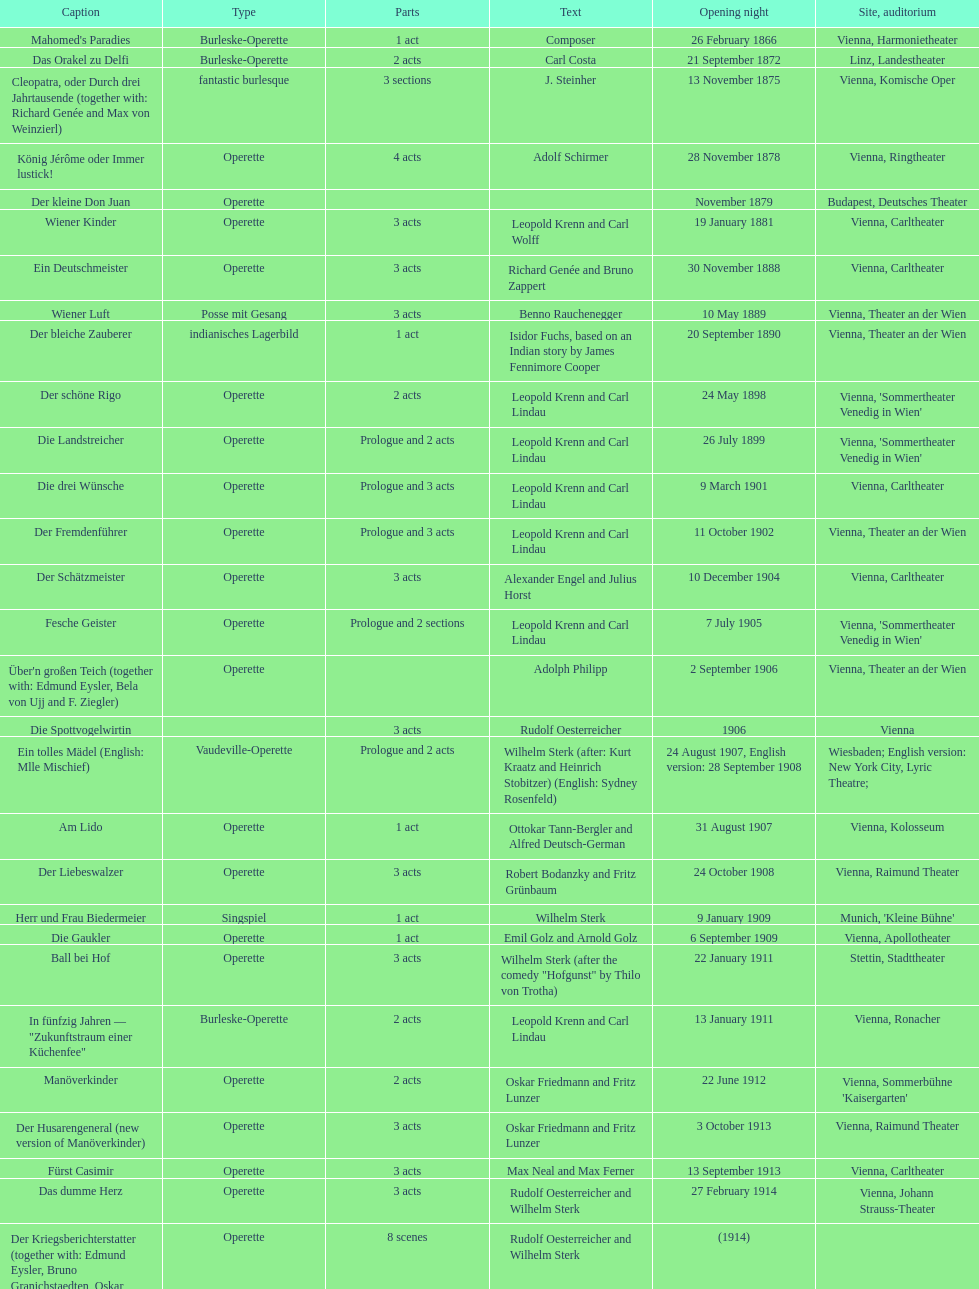All the dates are no later than what year? 1958. 